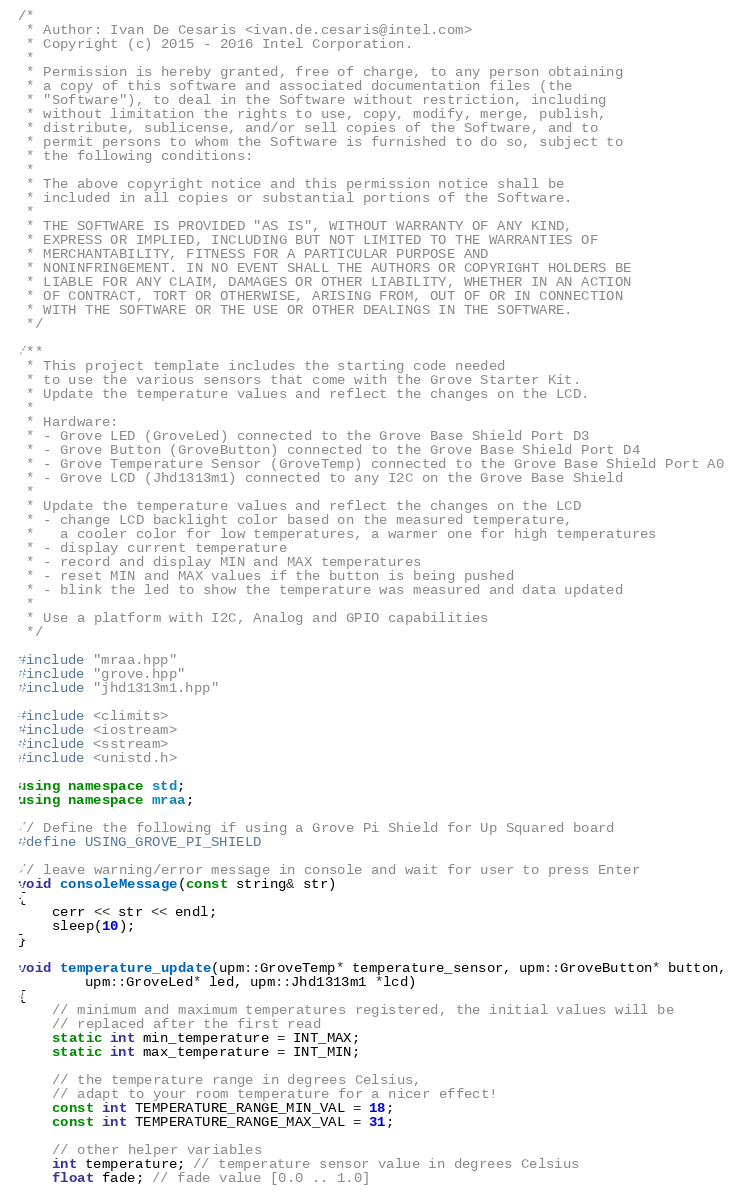<code> <loc_0><loc_0><loc_500><loc_500><_C++_>/*
 * Author: Ivan De Cesaris <ivan.de.cesaris@intel.com>
 * Copyright (c) 2015 - 2016 Intel Corporation.
 *
 * Permission is hereby granted, free of charge, to any person obtaining
 * a copy of this software and associated documentation files (the
 * "Software"), to deal in the Software without restriction, including
 * without limitation the rights to use, copy, modify, merge, publish,
 * distribute, sublicense, and/or sell copies of the Software, and to
 * permit persons to whom the Software is furnished to do so, subject to
 * the following conditions:
 *
 * The above copyright notice and this permission notice shall be
 * included in all copies or substantial portions of the Software.
 *
 * THE SOFTWARE IS PROVIDED "AS IS", WITHOUT WARRANTY OF ANY KIND,
 * EXPRESS OR IMPLIED, INCLUDING BUT NOT LIMITED TO THE WARRANTIES OF
 * MERCHANTABILITY, FITNESS FOR A PARTICULAR PURPOSE AND
 * NONINFRINGEMENT. IN NO EVENT SHALL THE AUTHORS OR COPYRIGHT HOLDERS BE
 * LIABLE FOR ANY CLAIM, DAMAGES OR OTHER LIABILITY, WHETHER IN AN ACTION
 * OF CONTRACT, TORT OR OTHERWISE, ARISING FROM, OUT OF OR IN CONNECTION
 * WITH THE SOFTWARE OR THE USE OR OTHER DEALINGS IN THE SOFTWARE.
 */

/**
 * This project template includes the starting code needed
 * to use the various sensors that come with the Grove Starter Kit.
 * Update the temperature values and reflect the changes on the LCD.
 *
 * Hardware:
 * - Grove LED (GroveLed) connected to the Grove Base Shield Port D3
 * - Grove Button (GroveButton) connected to the Grove Base Shield Port D4
 * - Grove Temperature Sensor (GroveTemp) connected to the Grove Base Shield Port A0
 * - Grove LCD (Jhd1313m1) connected to any I2C on the Grove Base Shield
 *
 * Update the temperature values and reflect the changes on the LCD
 * - change LCD backlight color based on the measured temperature,
 *   a cooler color for low temperatures, a warmer one for high temperatures
 * - display current temperature
 * - record and display MIN and MAX temperatures
 * - reset MIN and MAX values if the button is being pushed
 * - blink the led to show the temperature was measured and data updated
 *
 * Use a platform with I2C, Analog and GPIO capabilities
 */

#include "mraa.hpp"
#include "grove.hpp"
#include "jhd1313m1.hpp"

#include <climits>
#include <iostream>
#include <sstream>
#include <unistd.h>

using namespace std;
using namespace mraa;

// Define the following if using a Grove Pi Shield for Up Squared board
#define USING_GROVE_PI_SHIELD

// leave warning/error message in console and wait for user to press Enter
void consoleMessage(const string& str)
{
    cerr << str << endl;
    sleep(10);
}

void temperature_update(upm::GroveTemp* temperature_sensor, upm::GroveButton* button,
        upm::GroveLed* led, upm::Jhd1313m1 *lcd)
{
    // minimum and maximum temperatures registered, the initial values will be
    // replaced after the first read
    static int min_temperature = INT_MAX;
    static int max_temperature = INT_MIN;

    // the temperature range in degrees Celsius,
    // adapt to your room temperature for a nicer effect!
    const int TEMPERATURE_RANGE_MIN_VAL = 18;
    const int TEMPERATURE_RANGE_MAX_VAL = 31;

    // other helper variables
    int temperature; // temperature sensor value in degrees Celsius
    float fade; // fade value [0.0 .. 1.0]</code> 